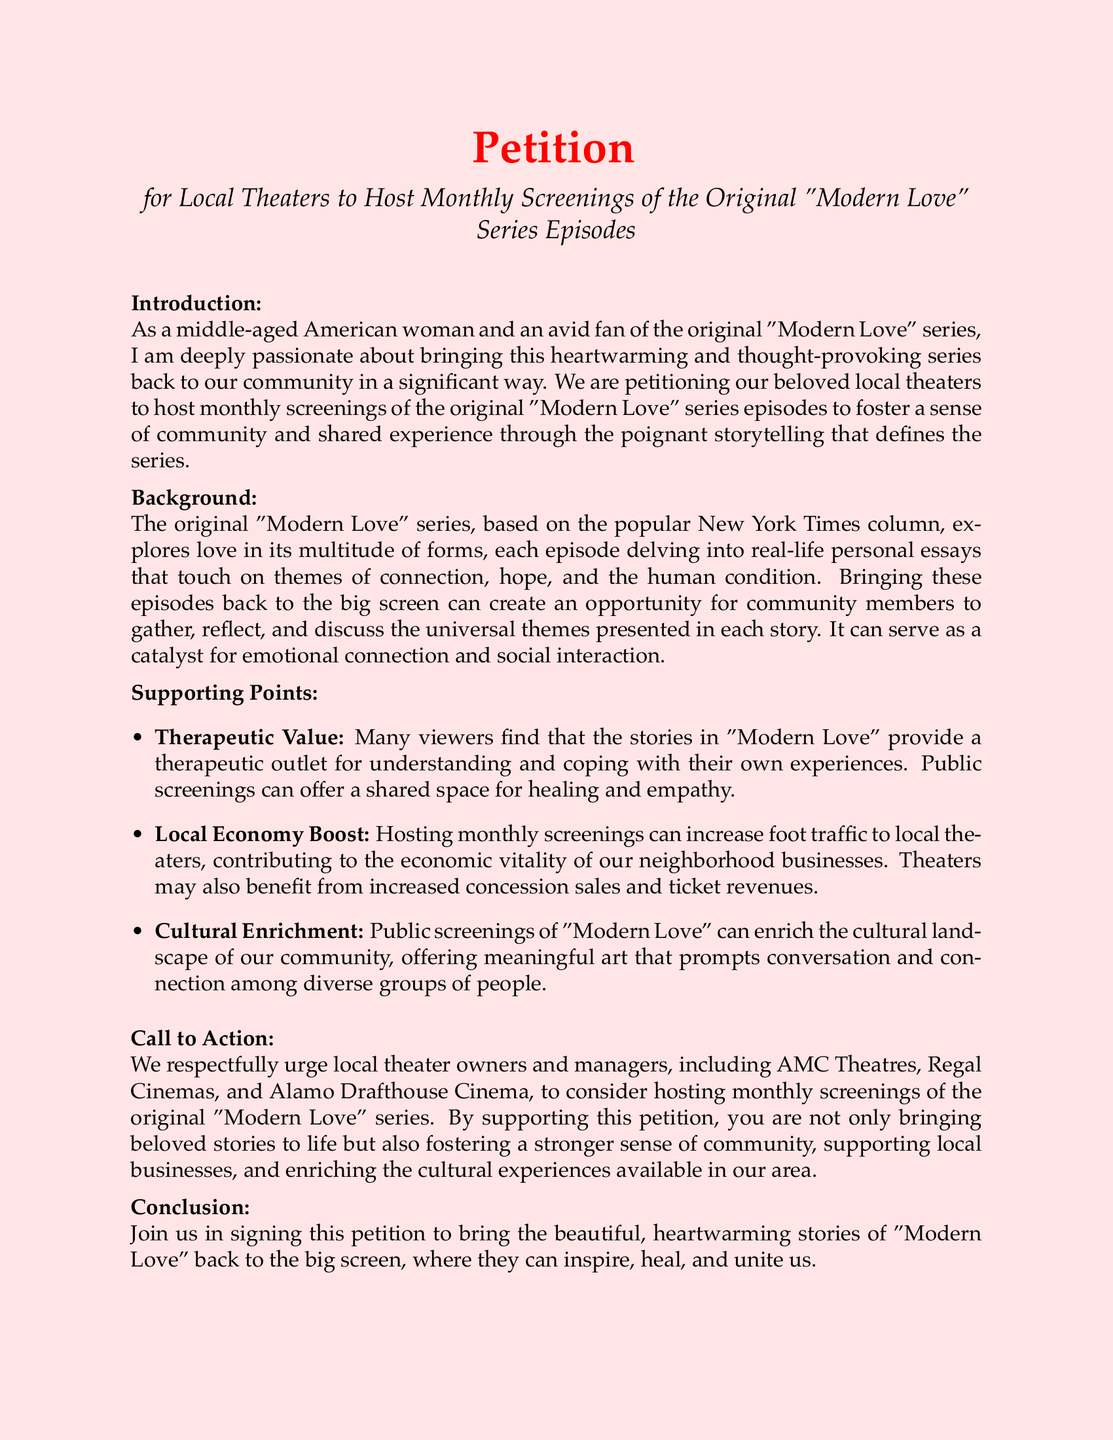What is the document about? The document is a petition for local theaters to host monthly screenings of the original "Modern Love" series episodes.
Answer: Petition for local theaters to host monthly screenings of the original "Modern Love" series episodes Who is the target audience for the petition? The petition targets local theater owners and managers like AMC Theatres, Regal Cinemas, and Alamo Drafthouse Cinema.
Answer: Local theater owners and managers What type of content is "Modern Love" based on? "Modern Love" is based on real-life personal essays that explore various forms of love.
Answer: Real-life personal essays What is one supporting point mentioned in the petition? One supporting point mentioned is the therapeutic value of the stories in "Modern Love."
Answer: Therapeutic Value How many main supporting points are listed? The document lists three main supporting points under "Supporting Points."
Answer: Three What do the screenings aim to foster? The screenings aim to foster a sense of community and shared experience.
Answer: Sense of community and shared experience What is the conclusion of the petition? The conclusion urges readers to join in signing the petition to bring "Modern Love" back to the big screen.
Answer: Join us in signing this petition How many signature lines are provided in the document? There are six signature lines provided at the end of the petition.
Answer: Six 